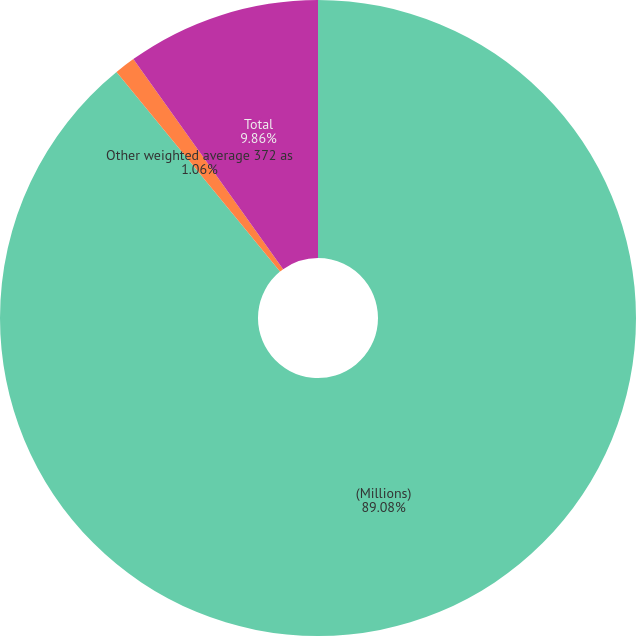<chart> <loc_0><loc_0><loc_500><loc_500><pie_chart><fcel>(Millions)<fcel>Other weighted average 372 as<fcel>Total<nl><fcel>89.07%<fcel>1.06%<fcel>9.86%<nl></chart> 